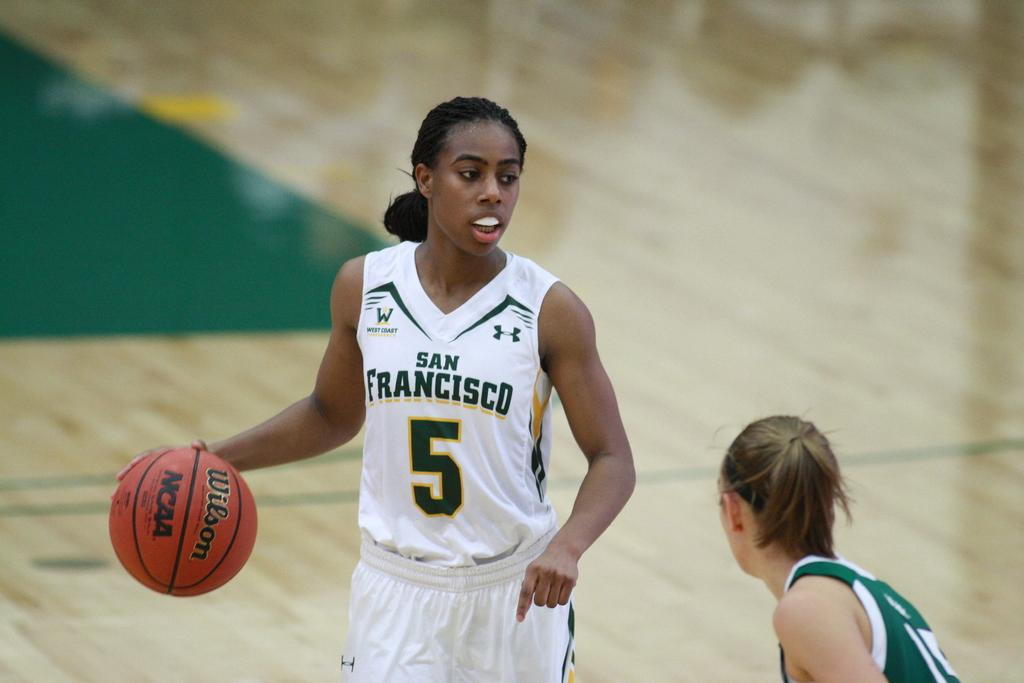<image>
Render a clear and concise summary of the photo. A female basketball player wears a uniform which reads San Francisco on the front. 